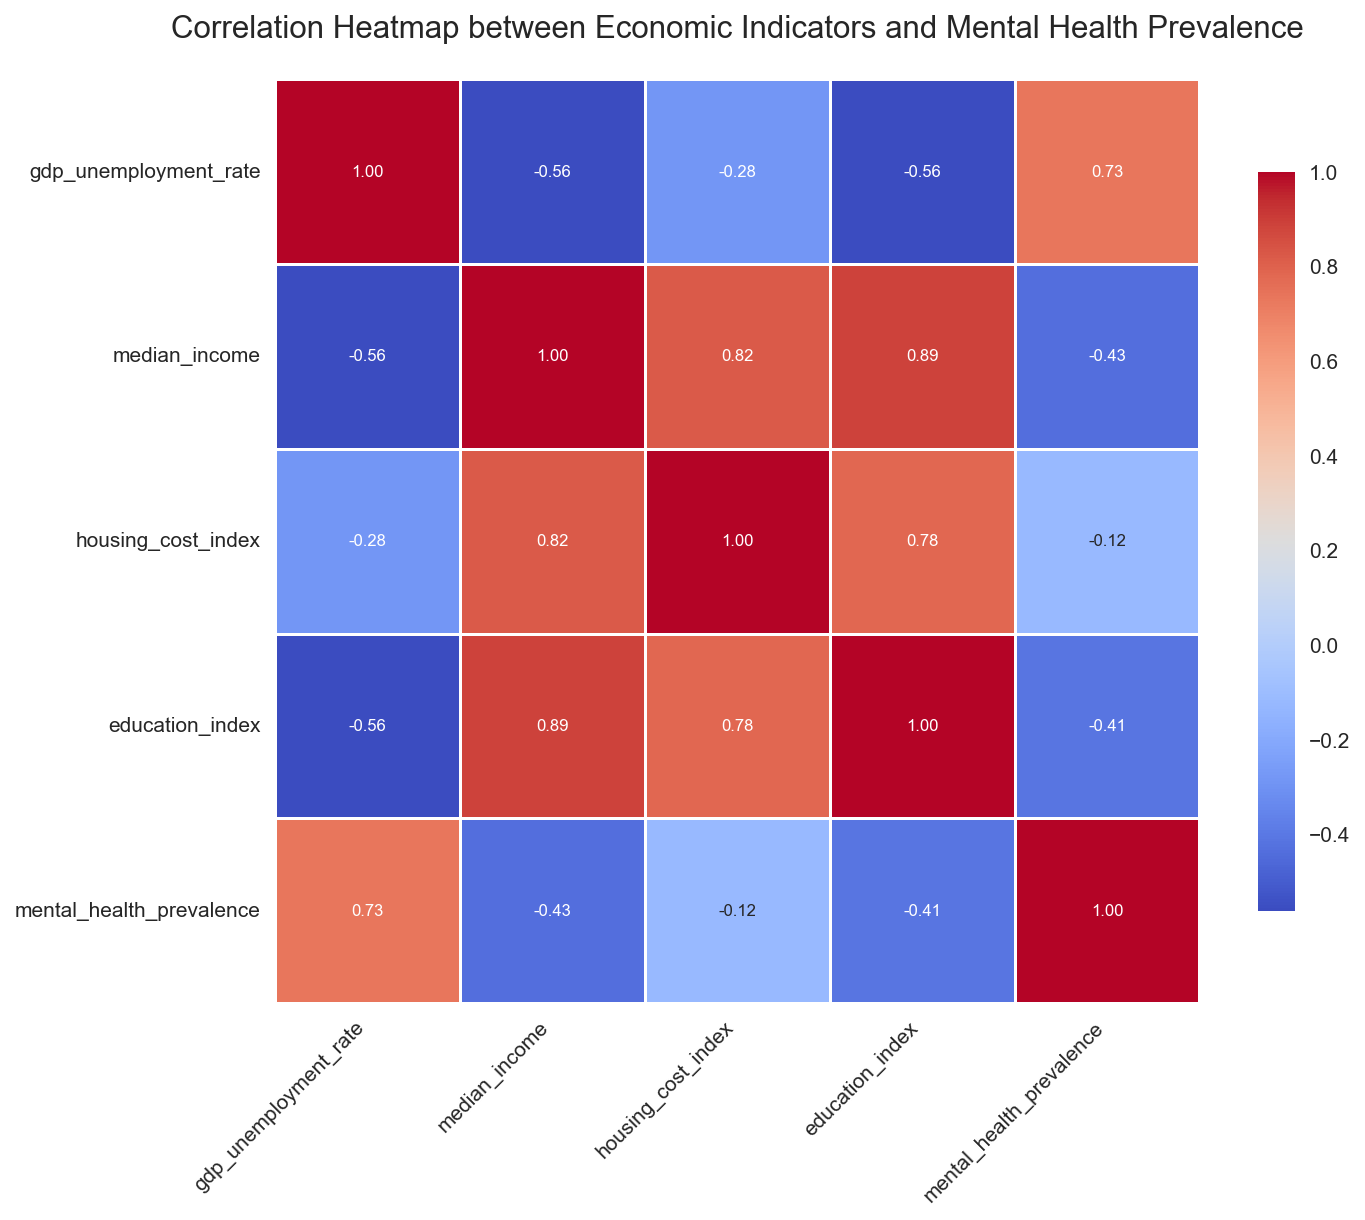Which economic indicator has the highest negative correlation with mental health prevalence? To find this, look for the lowest value in the 'mental_health_prevalence' row of the heatmap. The most negative correlation coefficient indicates the strongest negative correlation.
Answer: Education Index What are the two economic indicators that have the highest positive correlation? Look for the highest value in the heatmap excluding the diagonal, where indicators are perfectly correlated with themselves. Compare the correlation values in each cell to find the highest positive correlation coefficient.
Answer: Median Income and Housing Cost Index How does the correlation between median income and mental health prevalence compare to the correlation between education index and mental health prevalence? Locate the values of correlation between 'median_income' and 'mental_health_prevalence' and between 'education_index' and 'mental_health_prevalence'. Compare these two values to determine whether one is higher or lower.
Answer: Median Income is less negatively correlated than Education Index with mental health prevalence Which economic indicator has the weakest correlation with mental health prevalence? Identify the correlation value closest to zero in the 'mental_health_prevalence' row of the heatmap.
Answer: Median Income Is the correlation between GDP unemployment rate and housing cost index stronger or weaker than the correlation between housing cost index and education index? Locate the correlation values between 'gdp_unemployment_rate' and 'housing_cost_index' and between 'housing_cost_index' and 'education_index'. Compare their magnitudes to determine which is stronger.
Answer: Weaker What is the median value of the correlations excluding the diagonal? Extract all the non-diagonal correlation values from the heatmap, order them, and find the middle value.
Answer: 0.22 Does a higher median income correlate to a higher or lower prevalence of mental health issues? Find the correlation coefficient between 'median_income' and 'mental_health_prevalence'. A positive value indicates higher prevalence with higher income, while a negative value indicates lower prevalence.
Answer: Lower Prevalence 